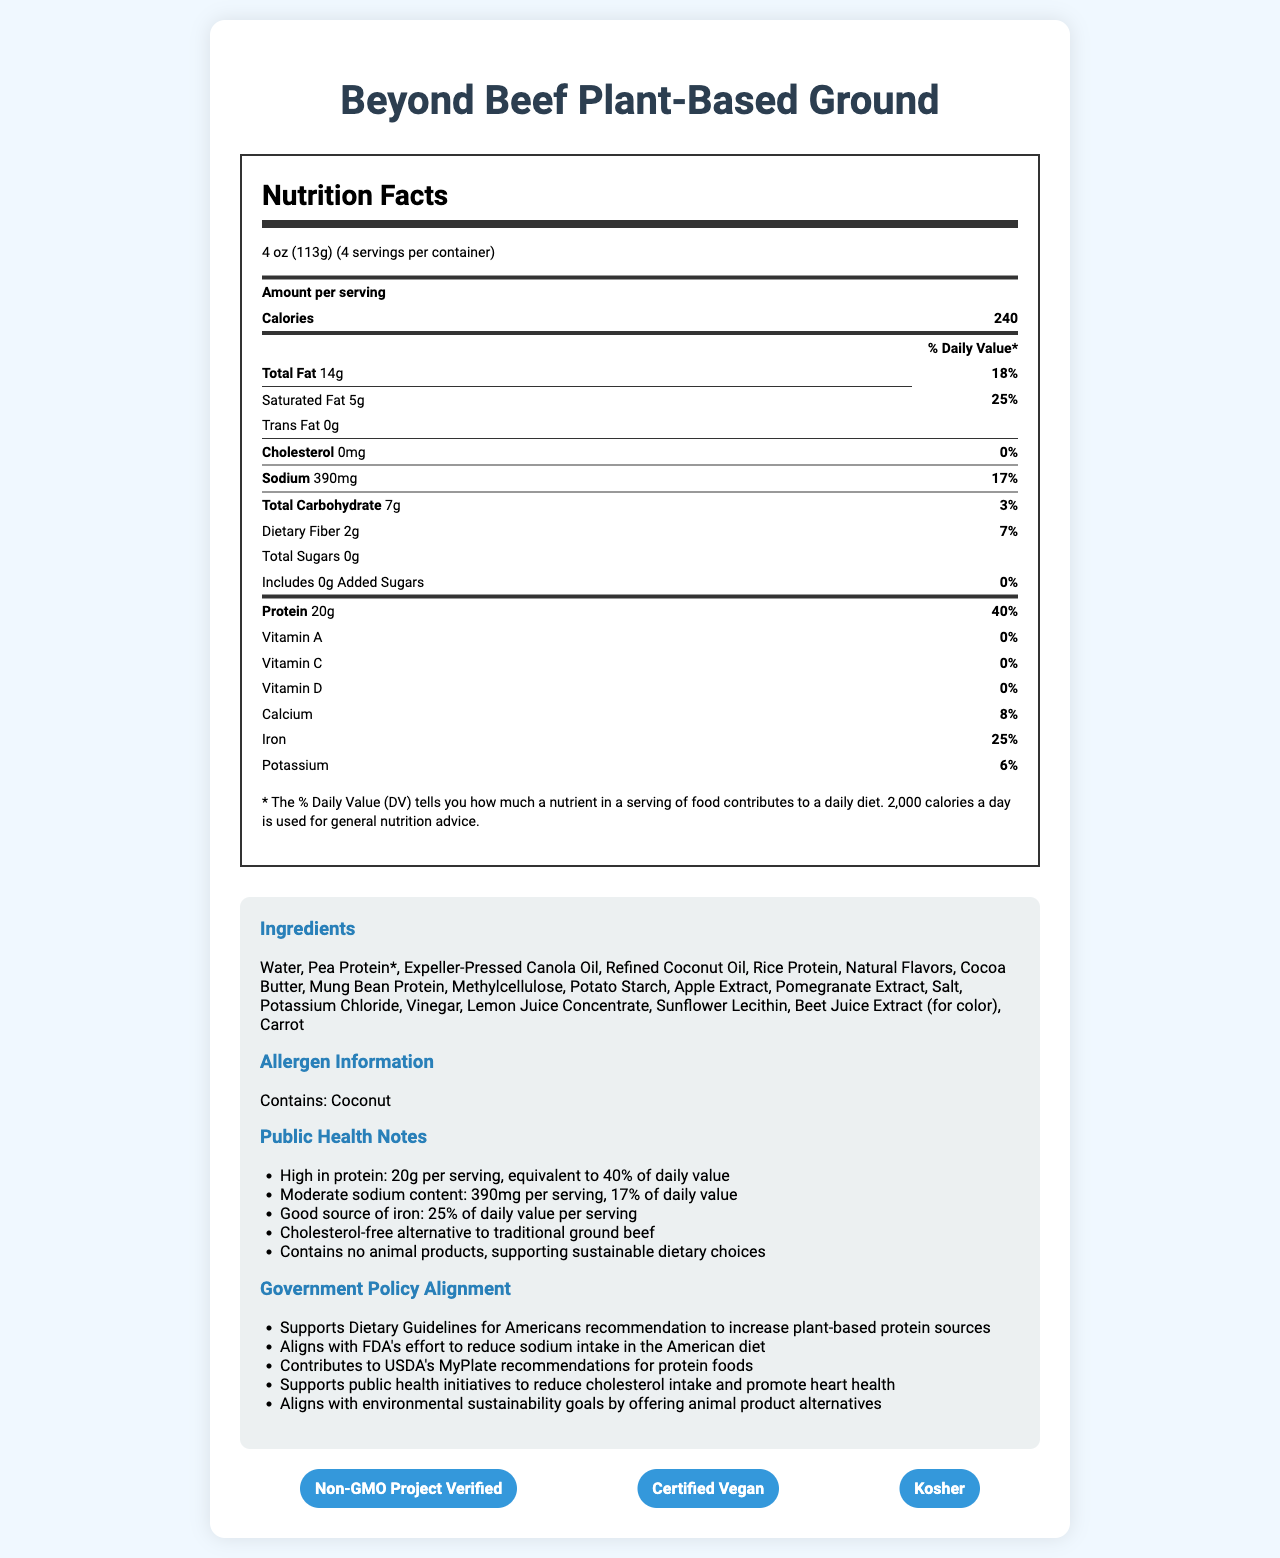what is the serving size of the Beyond Beef Plant-Based Ground? The serving size mentioned in the nutrition label section is 4 oz (113g).
Answer: 4 oz (113g) how much protein is in one serving of the Beyond Beef Plant-Based Ground? The nutrition label lists 20g of protein per serving.
Answer: 20g what is the sodium content per serving and its daily value percentage? The nutrition label section states that the sodium content per serving is 390mg, which is 17% of the daily value.
Answer: 390mg, 17% how much saturated fat does one serving contain? The nutrition label specifies that there are 5g of saturated fat per serving.
Answer: 5g what certifications does the Beyond Beef Plant-Based Ground have? The certifications section lists Non-GMO Project Verified, Certified Vegan, and Kosher.
Answer: Non-GMO Project Verified, Certified Vegan, Kosher which ingredient is included for coloring purposes? The ingredients list specifies that beet juice extract is used for color.
Answer: Beet Juice Extract what is the main allergen present in the product? The allergen information section indicates that the product contains coconut.
Answer: Coconut which of the following vitamins is not present in significant amounts in the Beyond Beef Plant-Based Ground?
A. Vitamin A
B. Calcium
C. Iron
D. Potassium According to the nutrition label, Vitamin A has 0% daily value, whereas Calcium, Iron, and Potassium have 8%, 25%, and 6% respectively.
Answer: A. Vitamin A True or False: One serving of Beyond Beef Plant-Based Ground contains added sugars. The nutrition label indicates that there are 0g of added sugars per serving.
Answer: False besides protein, what are two other public health benefits mentioned in the document? The public health notes section mentions that the product is a good source of iron (25% DV) and cholesterol-free, which are both beneficial to health.
Answer: 1. Good source of iron: 25% of daily value per serving
2. Cholesterol-free alternative to traditional ground beef is the Beyond Beef Plant-Based Ground involved in public health initiatives to promote heart health? The government policy alignment section notes that the product supports public health initiatives to reduce cholesterol intake and promote heart health.
Answer: Yes summarize the main ideas presented in the document. The document highlights nutrition facts, key ingredients, allergen information, public health benefits, government policy alignment, and certifications of the Beyond Beef Plant-Based Ground. It focuses on its high protein content, moderate sodium levels, sustainability, and health benefits.
Answer: The document provides detailed nutrition information about the Beyond Beef Plant-Based Ground, emphasizing its high protein content, moderate sodium levels, ingredient list, allergen information, certifications, public health notes, and alignment with government policies. The product offers a plant-based, cholesterol-free alternative to traditional ground beef, supports sustainable dietary choices, and aligns with various health and dietary guidelines. what is the environmental impact of this product compared to traditional ground beef? The document does not provide specific details or comparisons on the environmental impact of this product relative to traditional ground beef.
Answer: Cannot be determined 